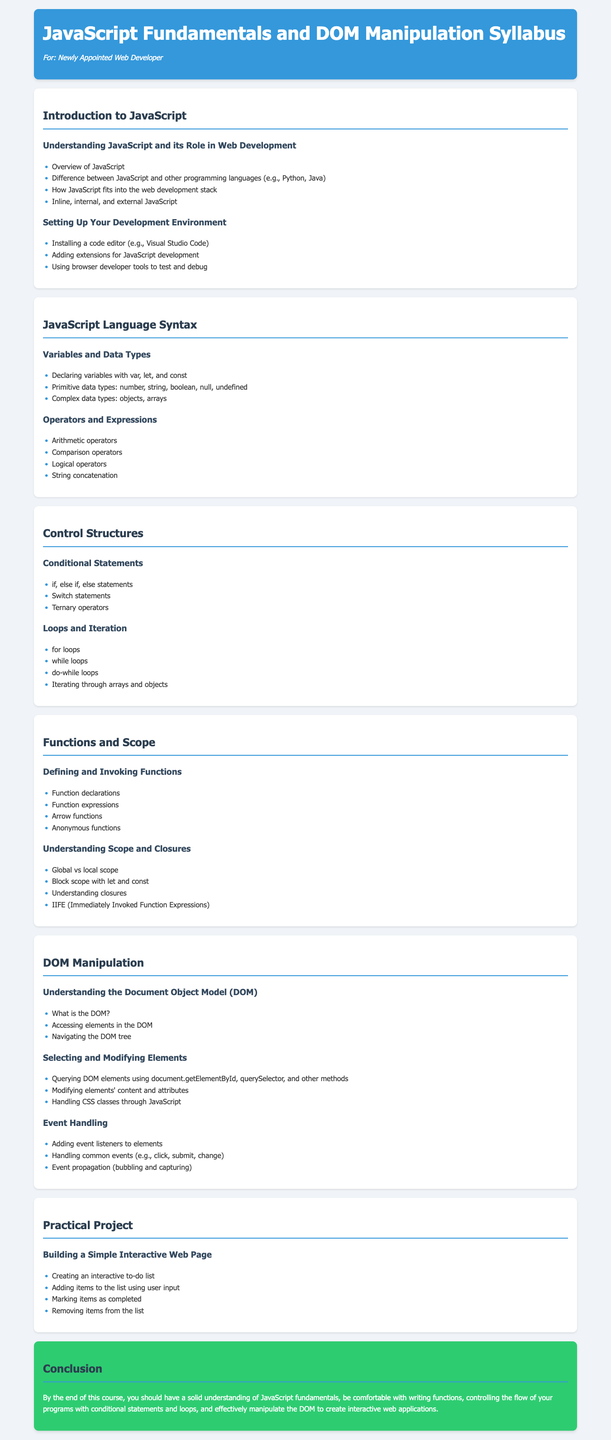What is the title of the syllabus? The title of the syllabus is stated in the `<title>` tag of the document.
Answer: JavaScript Fundamentals and DOM Manipulation Syllabus Who is the syllabus intended for? The intended audience is indicated in the header section of the document.
Answer: Newly Appointed Web Developer How many main modules are there in the syllabus? The total number of main modules can be counted from the document sections.
Answer: 5 What is the first topic covered under JavaScript Language Syntax? The first topic is listed in the corresponding module section.
Answer: Variables and Data Types Which JavaScript keyword is mentioned for declaring variables with block scope? The keyword for block scope is specifically mentioned in the section on variables.
Answer: let What type of project is suggested for practical application? The type of project is indicated in the practical project module.
Answer: Interactive Web Page What is one method mentioned for selecting DOM elements? The available method for selecting elements is outlined in the DOM Manipulation section.
Answer: document.getElementById What is the concluding remark about the course? The conclusion provides a summary of what the course aims to achieve.
Answer: Solid understanding of JavaScript fundamentals 